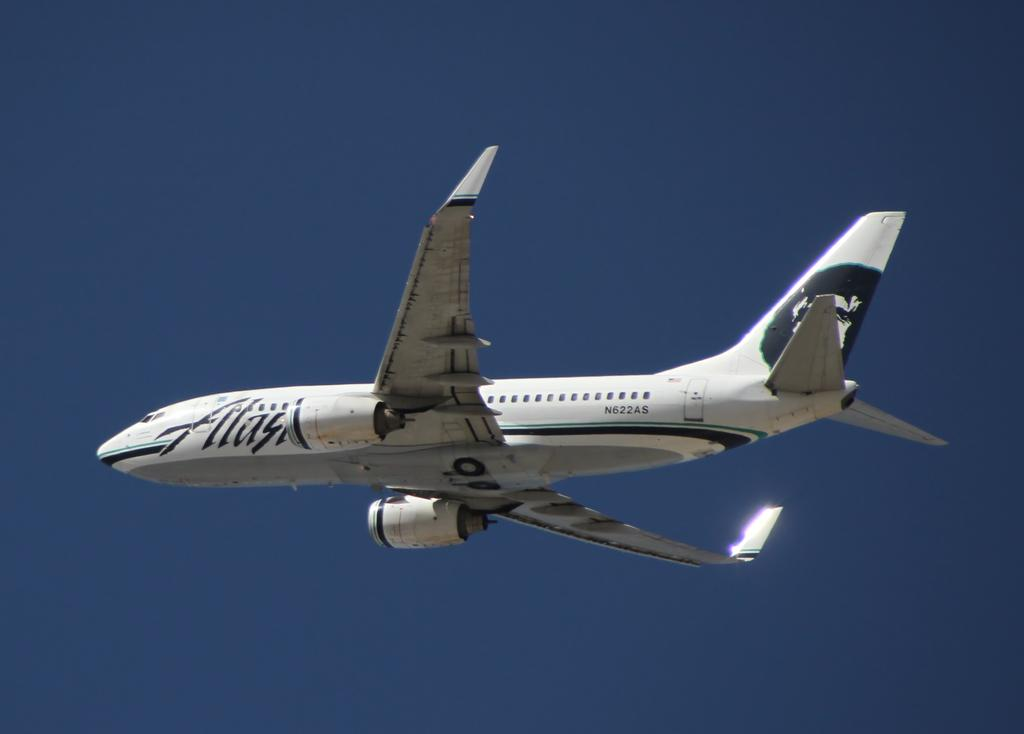What color is the airplane in the image? The airplane in the image is white. What is the airplane doing in the image? The airplane is flying in the sky. In which direction is the airplane flying? The airplane is flying towards the left. What type of print can be seen on the wings of the airplane? There is no print visible on the wings of the airplane in the image. What material is the spade made of that is being carried by the airplane? There is no spade being carried by the airplane in the image. 